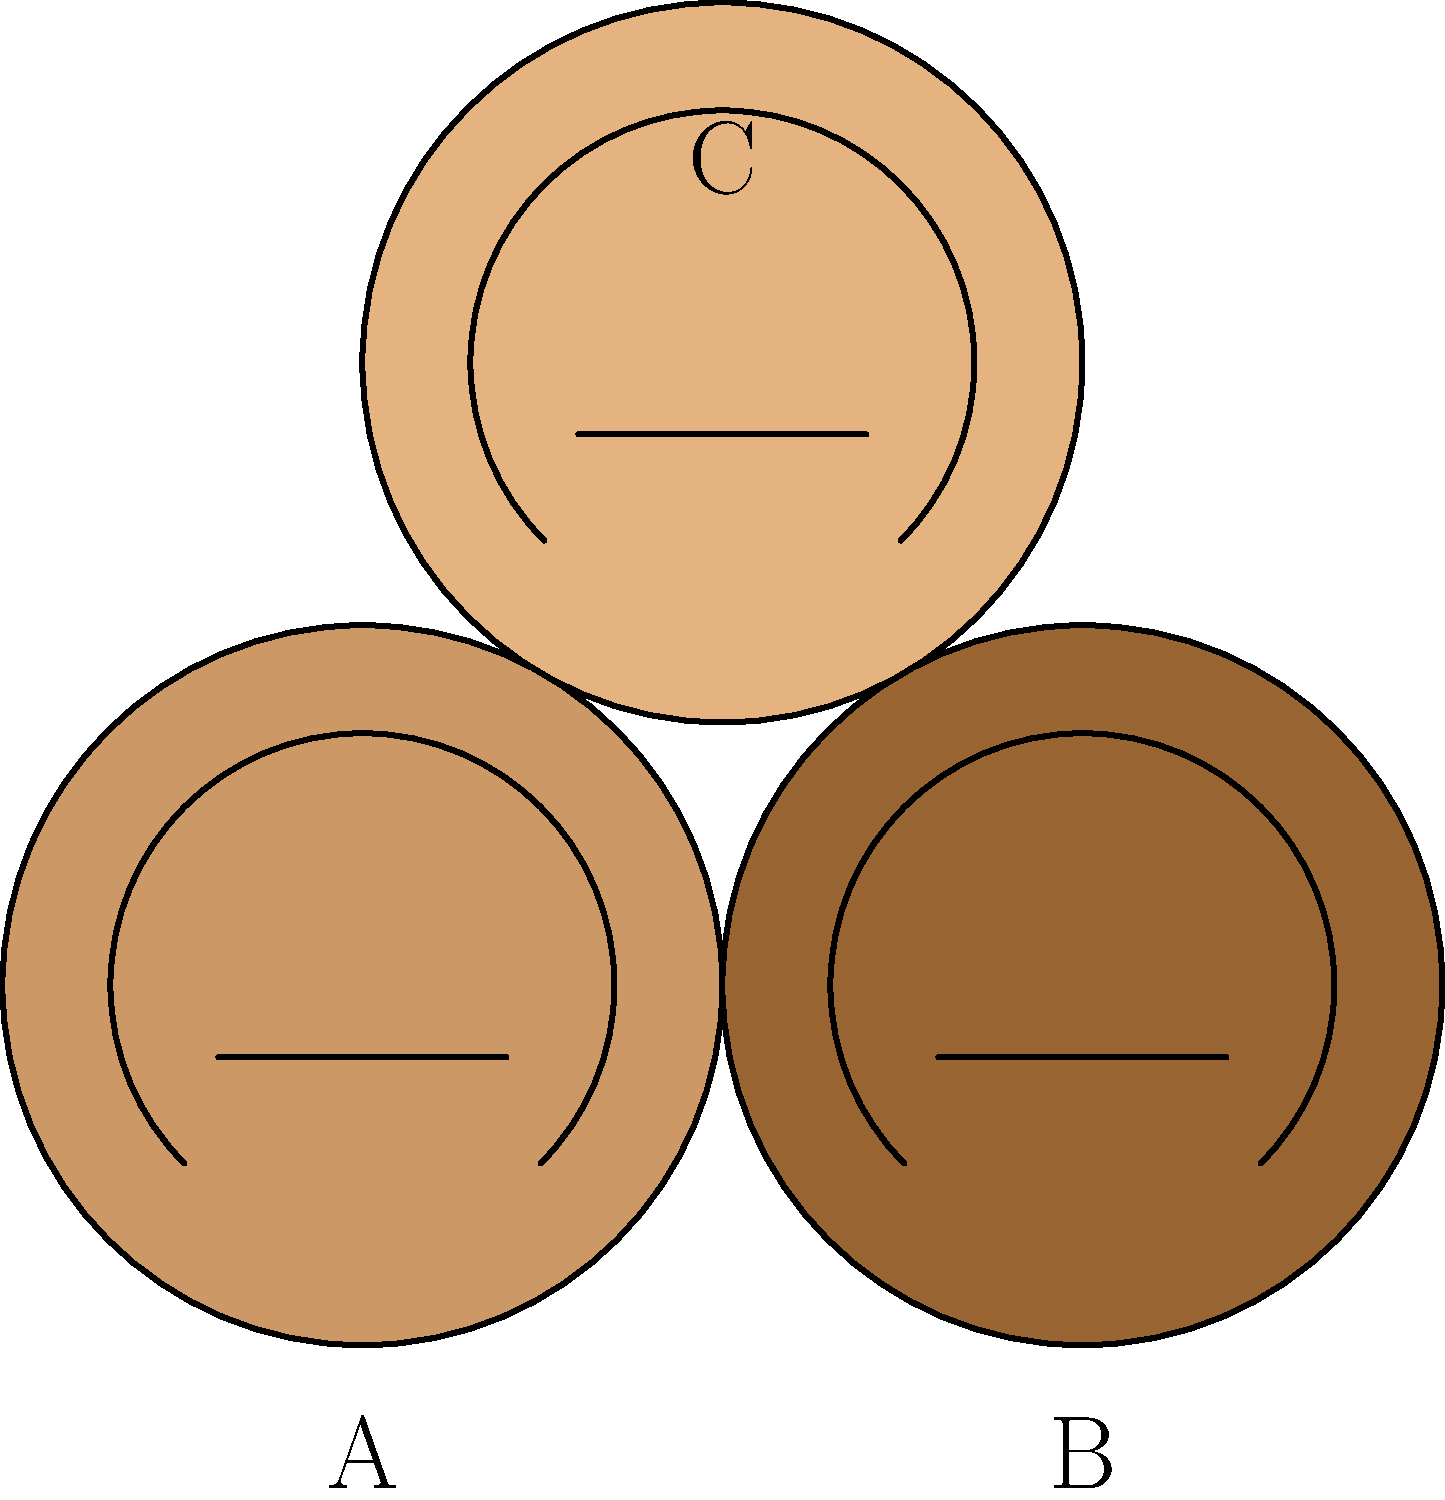Match the stylized portraits (A, B, C) to the following achievements:

1. First woman to fly solo across the Atlantic Ocean
2. First African American woman elected to the U.S. Congress
3. Founder of the American Red Cross

Which portrait corresponds to the achievement "First woman to fly solo across the Atlantic Ocean"? To answer this question, we need to identify the famous women represented by the stylized portraits and match them to their achievements. Let's go through the process step-by-step:

1. Identify the women based on the portraits and given achievements:
   A. Light skin tone - likely Amelia Earhart
   B. Dark skin tone - likely Shirley Chisholm
   C. Medium skin tone - likely Clara Barton

2. Match the women to their achievements:
   A. Amelia Earhart - First woman to fly solo across the Atlantic Ocean
   B. Shirley Chisholm - First African American woman elected to the U.S. Congress
   C. Clara Barton - Founder of the American Red Cross

3. The question asks specifically about the achievement "First woman to fly solo across the Atlantic Ocean"

4. This achievement corresponds to Amelia Earhart, who is represented by portrait A.

Therefore, the portrait that corresponds to the achievement "First woman to fly solo across the Atlantic Ocean" is portrait A.
Answer: A 